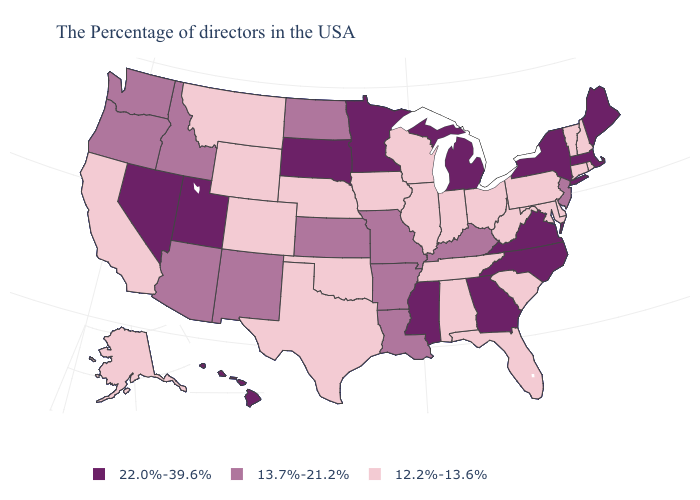Does Virginia have the same value as Idaho?
Concise answer only. No. What is the value of Indiana?
Short answer required. 12.2%-13.6%. Does Wyoming have a lower value than South Carolina?
Give a very brief answer. No. Does South Dakota have the lowest value in the MidWest?
Be succinct. No. What is the value of Alabama?
Write a very short answer. 12.2%-13.6%. Does New York have the highest value in the USA?
Short answer required. Yes. How many symbols are there in the legend?
Be succinct. 3. Name the states that have a value in the range 22.0%-39.6%?
Write a very short answer. Maine, Massachusetts, New York, Virginia, North Carolina, Georgia, Michigan, Mississippi, Minnesota, South Dakota, Utah, Nevada, Hawaii. Name the states that have a value in the range 12.2%-13.6%?
Keep it brief. Rhode Island, New Hampshire, Vermont, Connecticut, Delaware, Maryland, Pennsylvania, South Carolina, West Virginia, Ohio, Florida, Indiana, Alabama, Tennessee, Wisconsin, Illinois, Iowa, Nebraska, Oklahoma, Texas, Wyoming, Colorado, Montana, California, Alaska. Does New Hampshire have the lowest value in the Northeast?
Give a very brief answer. Yes. What is the lowest value in the USA?
Concise answer only. 12.2%-13.6%. Does Massachusetts have a higher value than Minnesota?
Concise answer only. No. What is the highest value in the West ?
Short answer required. 22.0%-39.6%. Name the states that have a value in the range 22.0%-39.6%?
Keep it brief. Maine, Massachusetts, New York, Virginia, North Carolina, Georgia, Michigan, Mississippi, Minnesota, South Dakota, Utah, Nevada, Hawaii. Does Georgia have a lower value than Washington?
Quick response, please. No. 